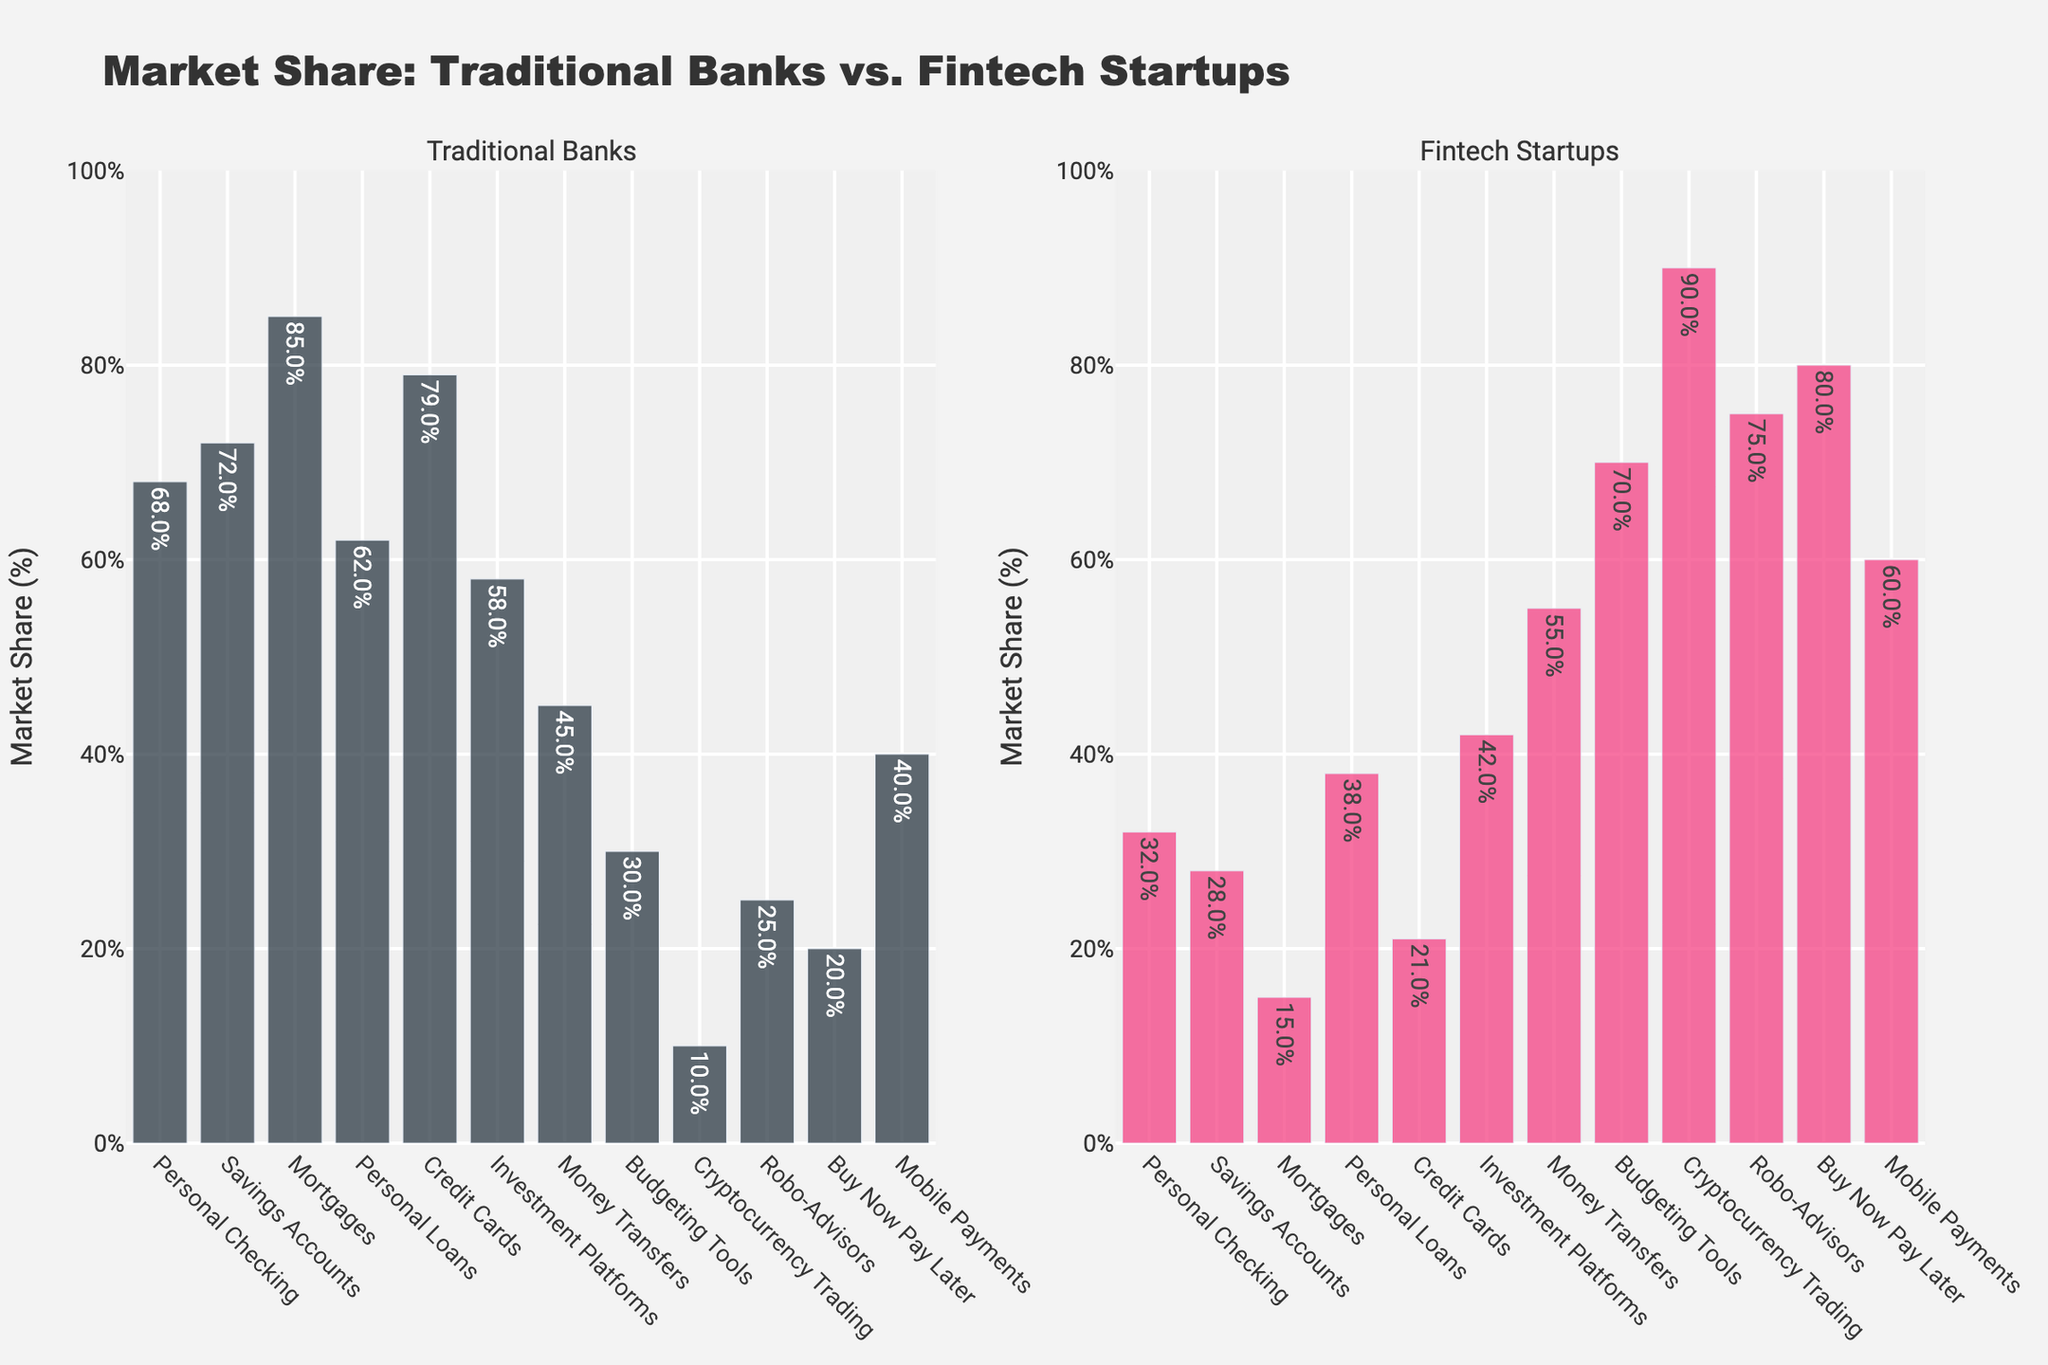Which service sees the highest market share by fintech startups? By examining the bars, we can see that for "Cryptocurrency Trading," the fintech startups' market share bar is the tallest, indicating the highest percentage.
Answer: Cryptocurrency Trading Which service has a greater market share for traditional banks compared to fintech startups? Most services have a higher traditional banks' market share, but by checking them individually, "Mortgages" has a significant difference with 85% for traditional banks compared to 15% for fintech startups.
Answer: Mortgages For which service do fintech startups hold more market share than traditional banks? By looking for where the fintech startups' bars are taller, we see that "Money Transfers," "Budgeting Tools," "Cryptocurrency Trading," "Robo-Advisors," and "Buy Now Pay Later" exceed traditional banks.
Answer: Money Transfers, Budgeting Tools, Cryptocurrency Trading, Robo-Advisors, Buy Now Pay Later Which service shows the smallest market share difference between traditional banks and fintech startups? For each service, calculate the absolute difference. "Personal Loans" has 62% for traditional banks and 38% for fintech startups, with an absolute difference of 24%, the smallest among all.
Answer: Personal Loans What is the combined market share of traditional banks and fintech startups for Mobile Payments? The market shares for traditional banks and fintech startups are 40% and 60%, respectively. Adding these together results in 100%.
Answer: 100% Which service is dominated by fintech startups in terms of market share? The service where fintech startups have the majority share is "Cryptocurrency Trading" with 90%, as this is the highest market share listed among all services.
Answer: Cryptocurrency Trading Which service has the least market share by traditional banks? The service "Cryptocurrency Trading" has the smallest share held by traditional banks with only 10%.
Answer: Cryptocurrency Trading What is the average market share for fintech startups across all services? Calculate the mean of fintech startups' market shares: (32+28+15+38+21+42+55+70+90+75+80+60)/12. The sum is 606, and dividing by 12 gives an average of 50.5%.
Answer: 50.5% How many services have a market share of 50% or more by fintech startups? By reviewing the fintech startups' percentages, five services have a market share of 50% or more: "Money Transfers," "Budgeting Tools," "Cryptocurrency Trading," "Robo-Advisors," and "Buy Now Pay Later."
Answer: 5 For which services does the market share of traditional banks exceed twice that of fintech startups? Determine where the traditional banks' market share is at least twice that of fintech startups. "Mortgages" is 85% traditional banks and 15% fintech startups (85/2 = 42.5 > 15%), and "Credit Cards" is 79% traditional banks and 21% fintech startups (79/2 = 39.5 > 21%).
Answer: Mortgages, Credit Cards 